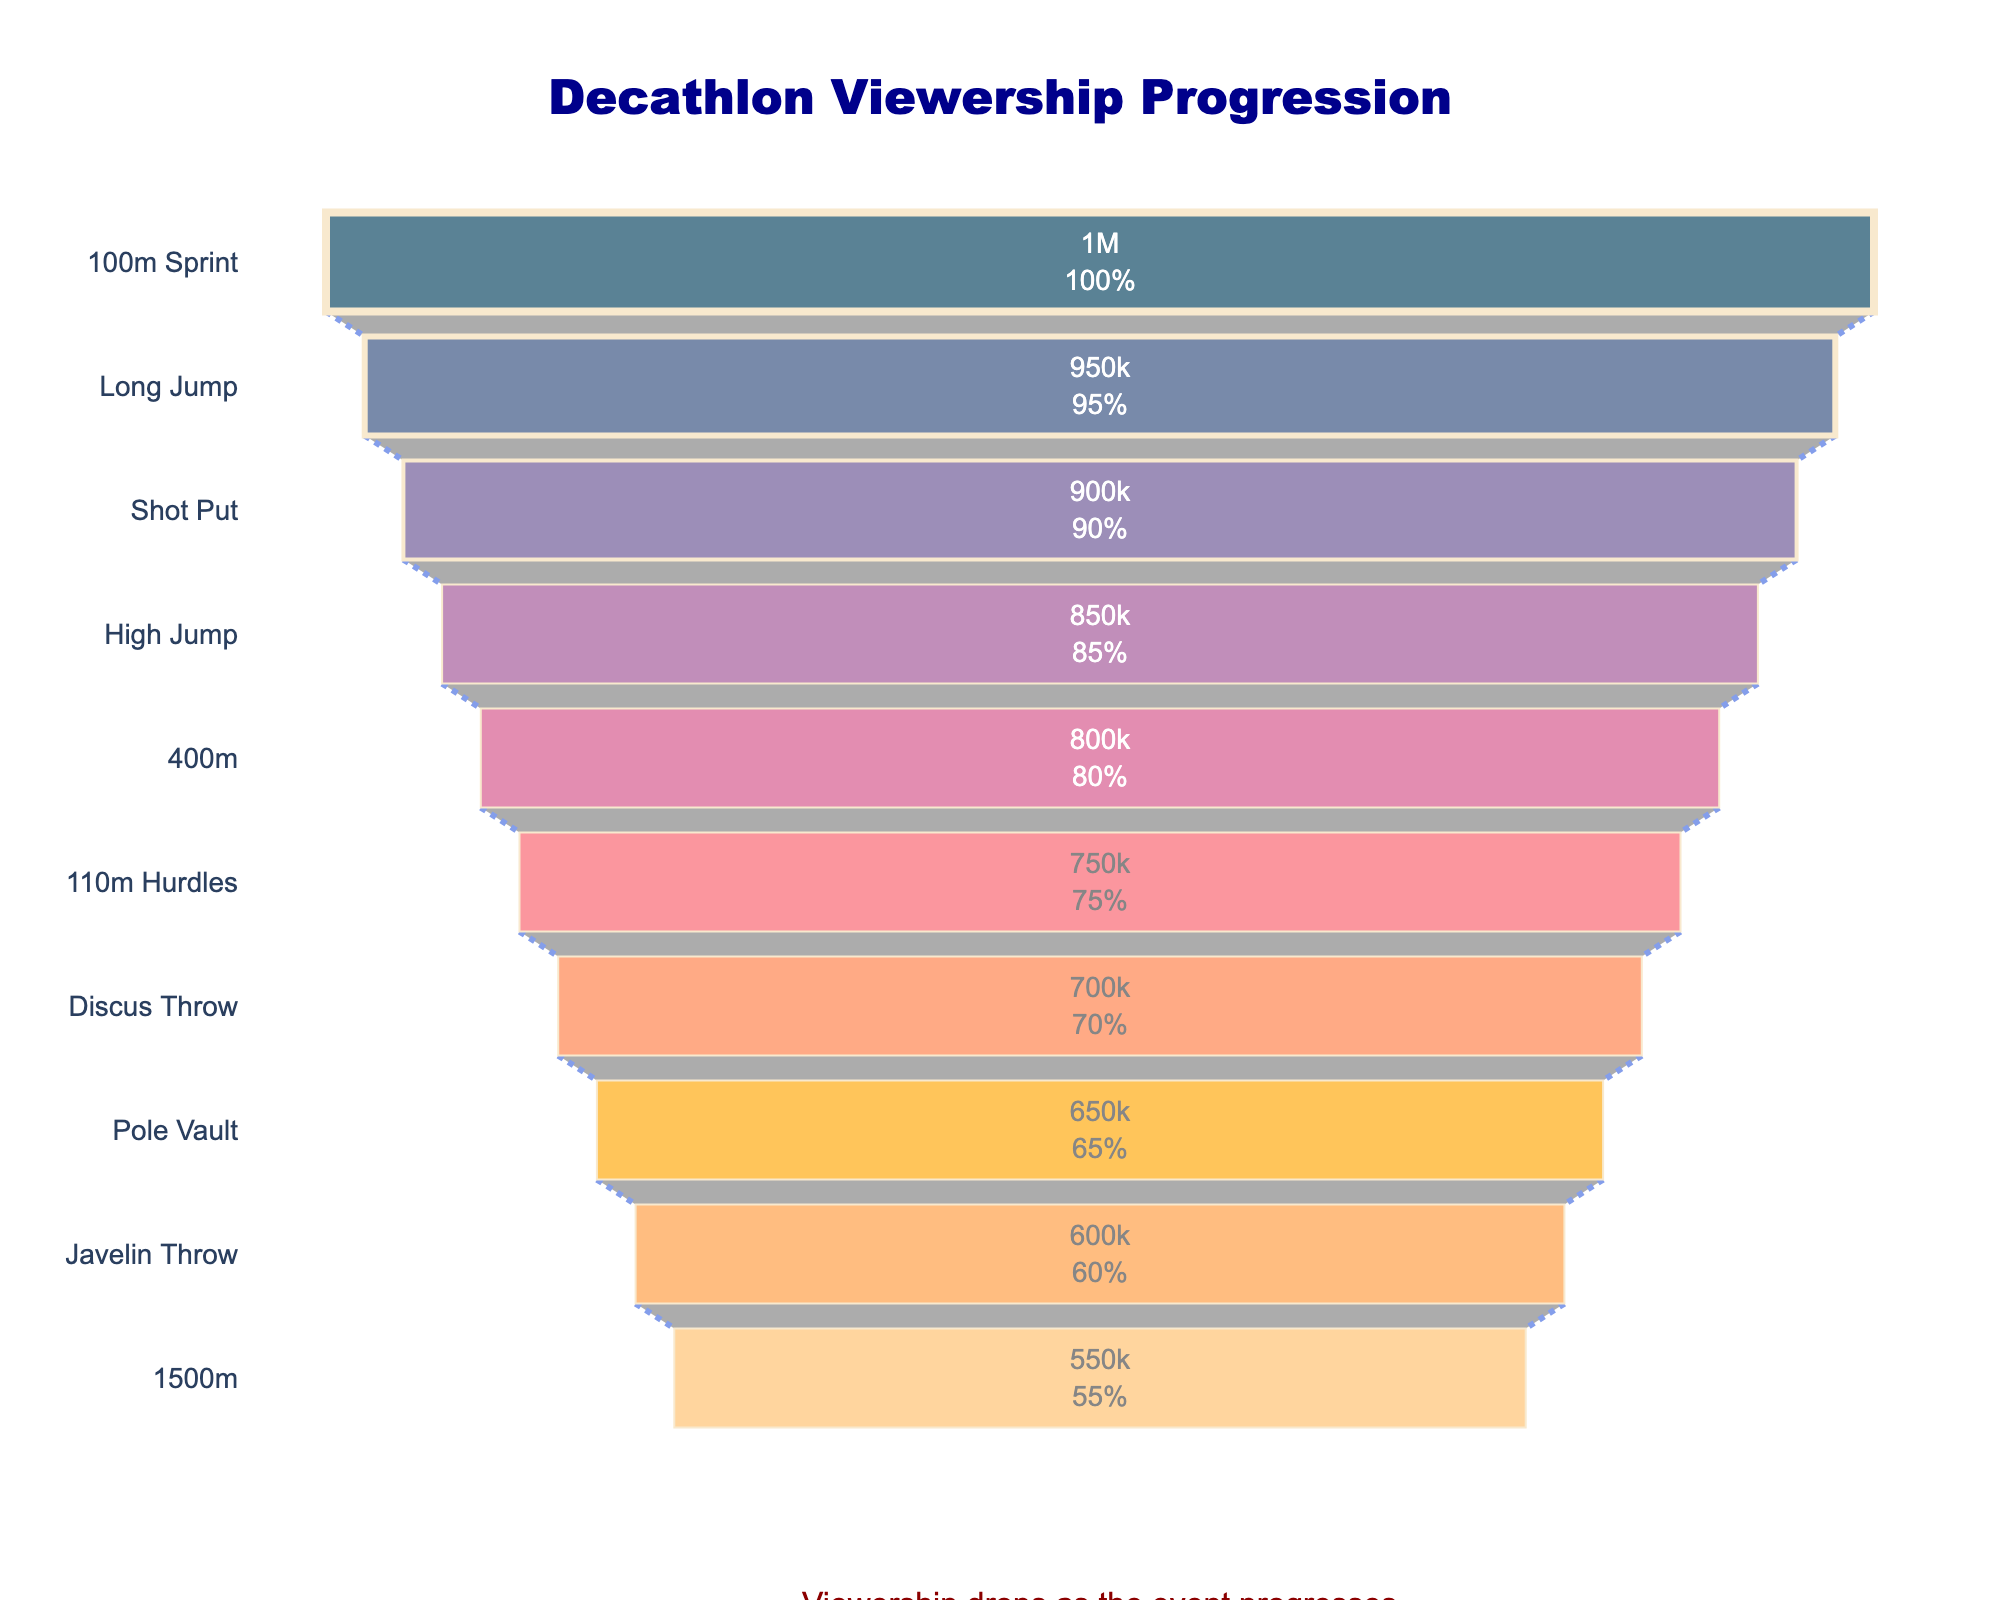What's the title of the chart? The title of the chart is placed at the top of the figure. It reads "Decathlon Viewership Progression" with an additional annotation below the funnel chart.
Answer: Decathlon Viewership Progression Which event had the highest viewership? The topmost event in the funnel chart represents the event with the highest viewership, which is "100m Sprint" with 1,000,000 viewers.
Answer: 100m Sprint What is the percentage of drop in viewership from the 100m Sprint to the 1500m? The initial viewership is 1,000,000 (100m Sprint) and the final viewership is 550,000 (1500m). The percentage drop is calculated as ((1,000,000 - 550,000) / 1,000,000) * 100 = 45%.
Answer: 45% Which event experienced the largest single drop in viewership? The chart indicates the difference between subsequent events. The largest single drop appears between the 100m Sprint and Long Jump, with a drop of 50,000 viewers (1,000,000 - 950,000).
Answer: 100m Sprint to Long Jump Are there any events where the drop in viewership is less than 50,000? By looking at the differences between successive events in the funnel chart, the drops from "Long Jump" to "Shot Put", "Shot Put" to "High Jump", "High Jump" to "400m", etc., are all exactly 50,000 viewers, not less.
Answer: No Which event marks the halfway point in total viewership from the start to the end? The halfway point can be approximated by finding the middle cumulative point. Cumulative viewership drop shows that "Pole Vault" is about halfway from the start with 650,000 viewers, close to the midpoint between 1,000,000 and 550,000.
Answer: Pole Vault What is the color of the segment representing the Discus Throw event? The color pattern in the funnel chart shows Discus Throw in an orange shade. By referencing the color list, it is identified as "#ff7c43".
Answer: Orange (#ff7c43) What is the most significant insight observable from the chart? The annotation and overall shape indicate the significant insight: viewership consistently declines as the decathlon progresses.
Answer: Viewership drops as the event progresses What percentage of the initial viewership remains by the 1500m event? The viewership for the 1500m event is 550,000. To find the percentage of the initial viewers remaining, divide 550,000 by 1,000,000 and multiply by 100, which equals 55%.
Answer: 55% 